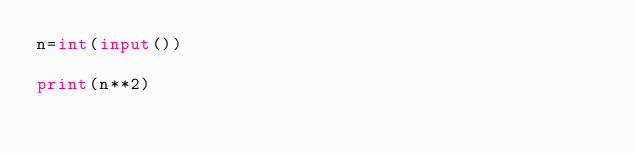<code> <loc_0><loc_0><loc_500><loc_500><_Python_>n=int(input())

print(n**2)
</code> 